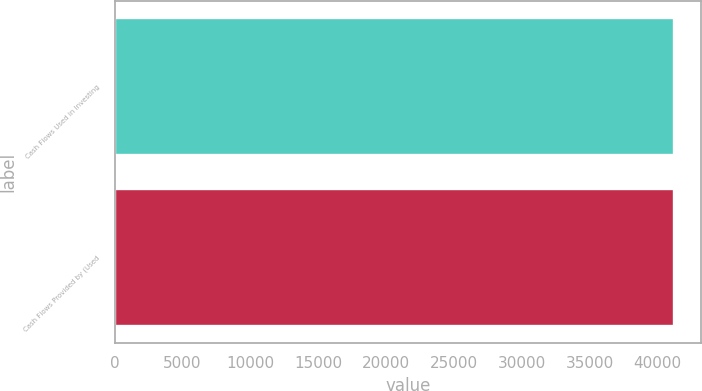Convert chart to OTSL. <chart><loc_0><loc_0><loc_500><loc_500><bar_chart><fcel>Cash Flows Used in Investing<fcel>Cash Flows Provided by (Used<nl><fcel>41173<fcel>41173.1<nl></chart> 